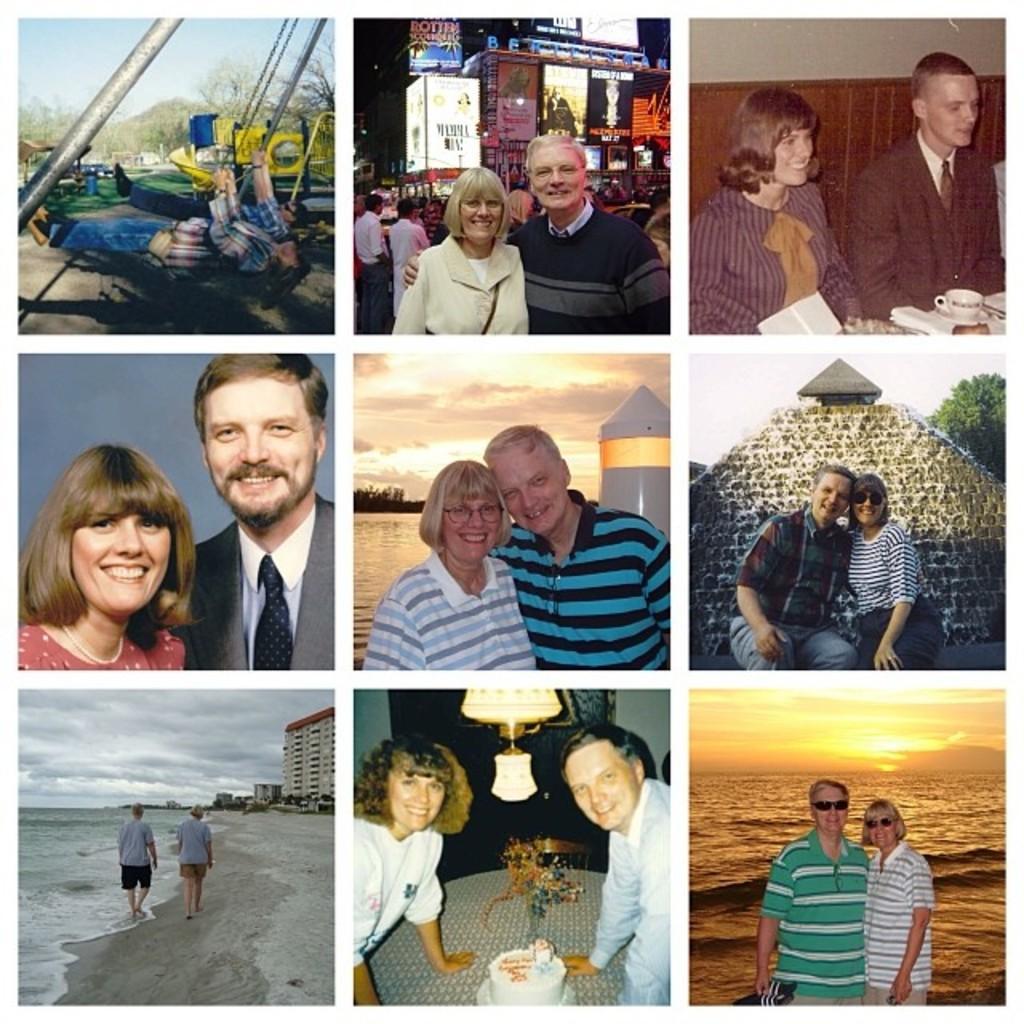How would you summarize this image in a sentence or two? In this image there is collage of photos of two persons. Right bottom of image two persons are wearing shirts and goggles. They are standing before water having tides. Top of it there is sky having sun. Left bottom of image there are two persons walking on the land. Beside them there is water. On land there are few buildings. 